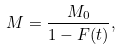Convert formula to latex. <formula><loc_0><loc_0><loc_500><loc_500>M = \frac { M _ { 0 } } { 1 - F ( t ) } ,</formula> 